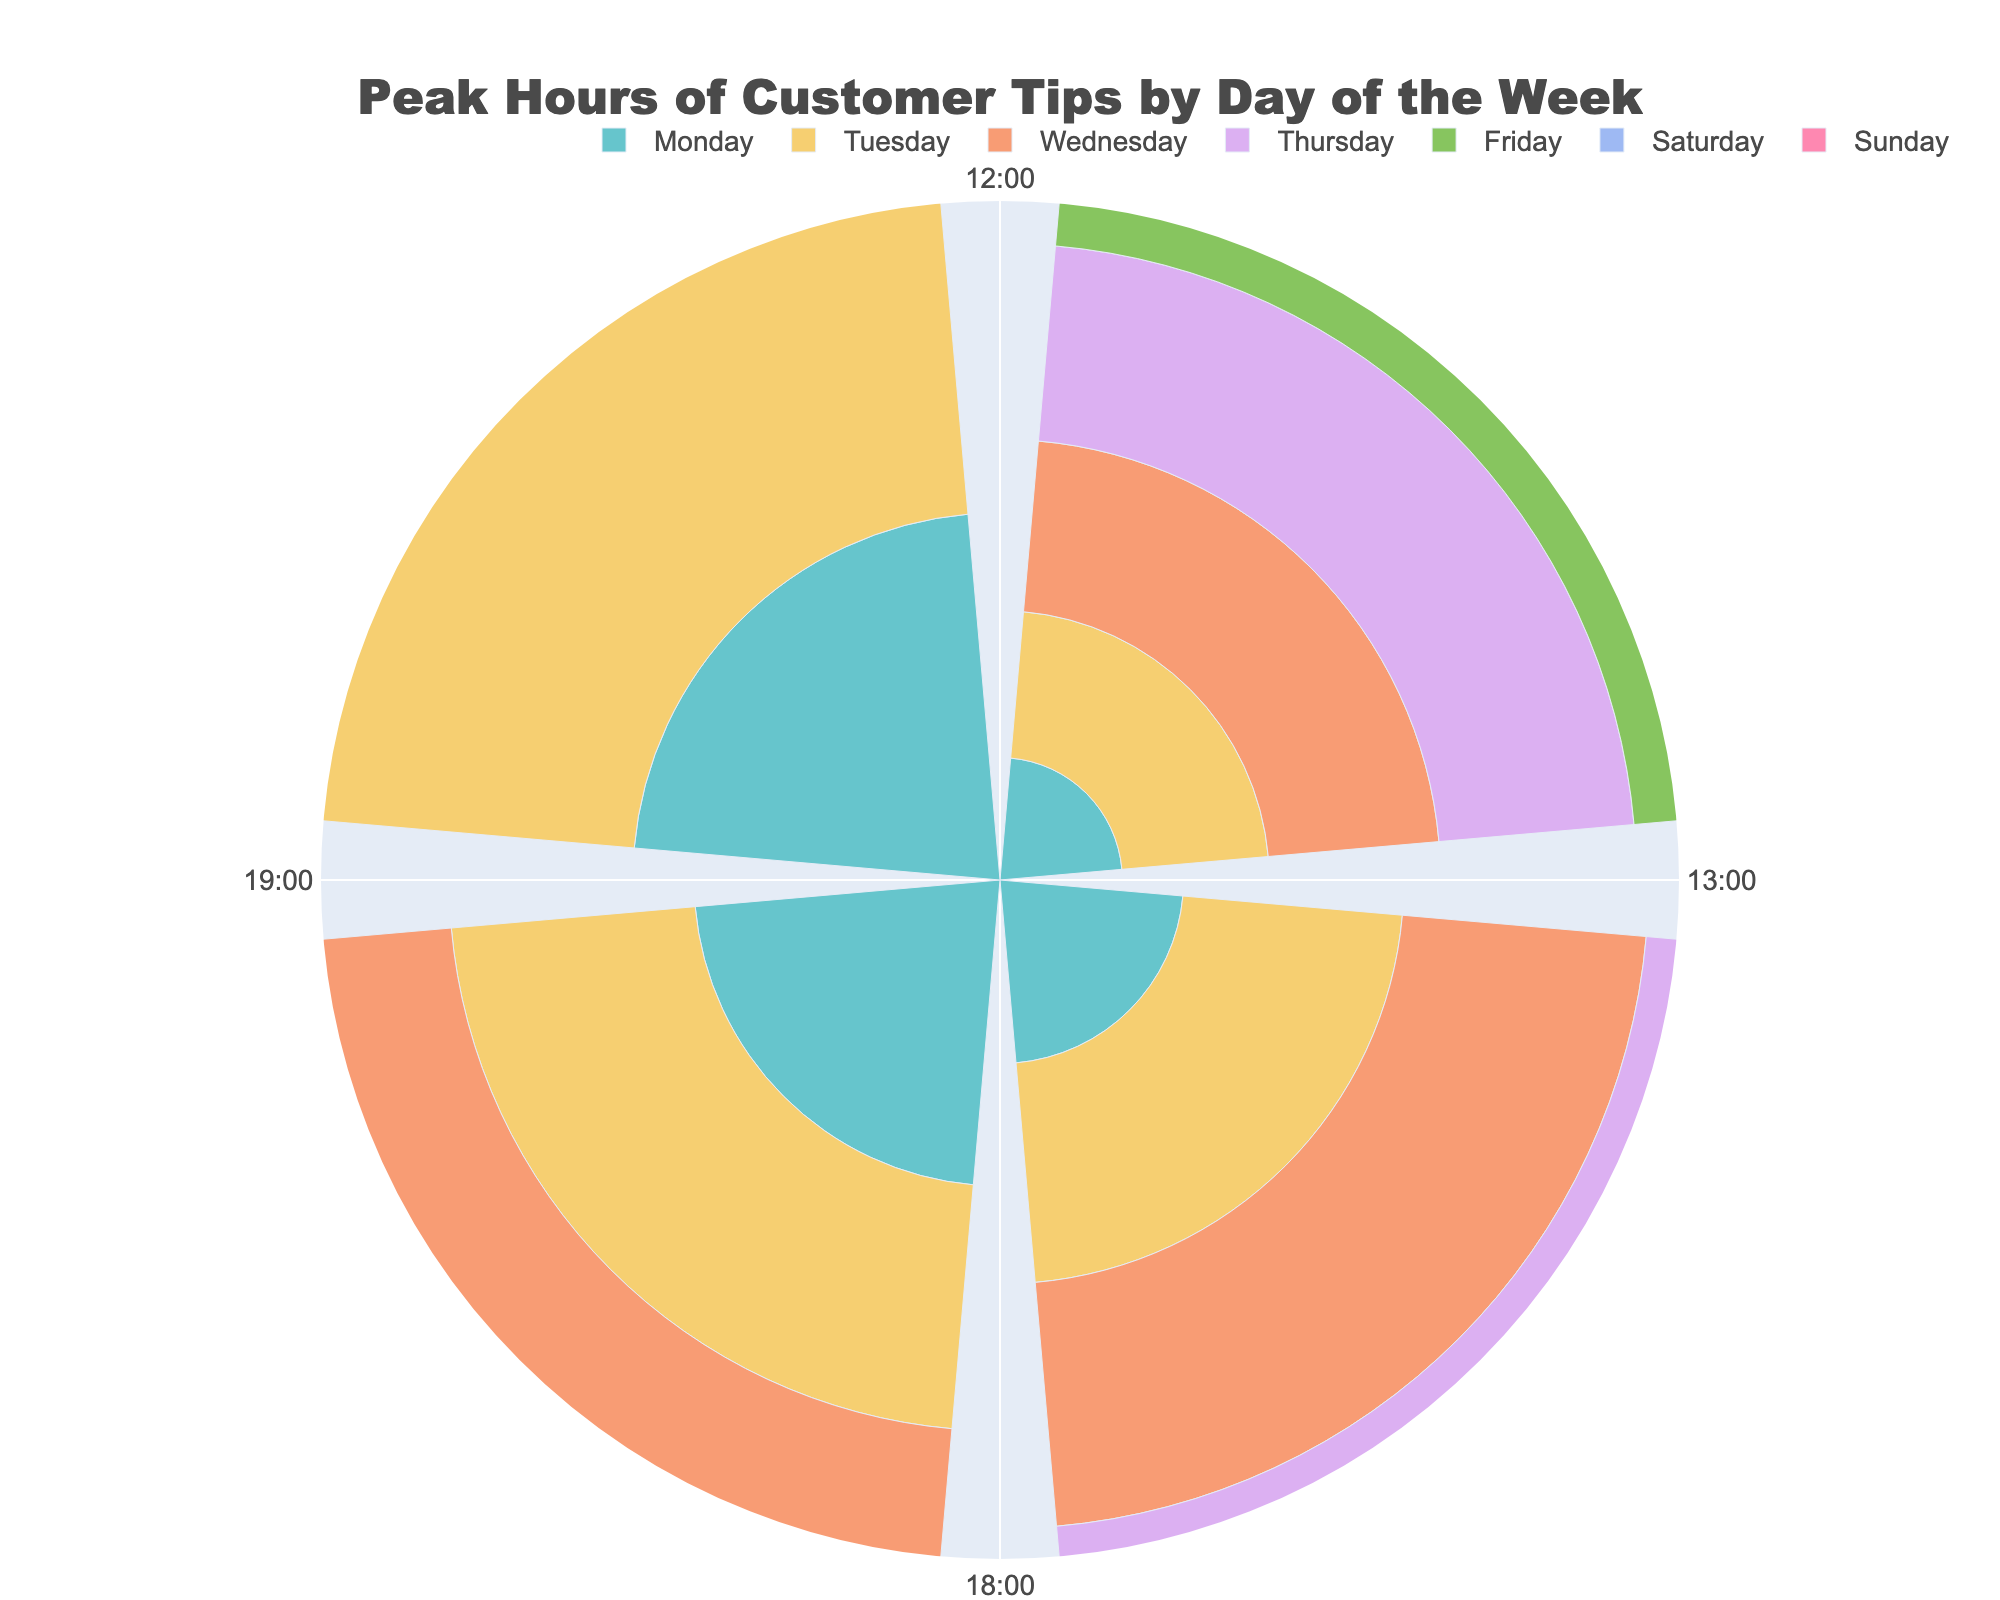What is the title of the rose chart? The title is usually placed prominently at the top of the figure. In this case, it reads "Peak Hours of Customer Tips by Day of the Week".
Answer: Peak Hours of Customer Tips by Day of the Week Which day has the highest average tips at 19:00? Look at the 19:00 data points for each day. The longest bar at 19:00 corresponds to Saturday with an average tip amount of 50.
Answer: Saturday What are the tick labels around the polar axis? The tick labels can be found around the angular axis of the polar chart. They are "12:00", "13:00", "18:00", and "19:00".
Answer: 12:00, 13:00, 18:00, 19:00 On which day do the average tips at 12:00 show the lowest value, and what is that value? Compare the lengths of the bars at 12:00 for each day. The shortest bar at 12:00 is on Monday with an average tip of 10.
Answer: Monday, 10 What is the color of the bars representing Friday? The colors for each day can be identified by looking at the legend. According to the color scheme, the bars for Friday are shown in a specific pastel color.
Answer: Pastel color for Friday (refer to the chart) Which day shows the greatest increase in average tips from 13:00 to 19:00? Compare the average tips at 13:00 and 19:00 for each day and find the day with the largest difference. Saturday has an increase from 28 at 13:00 to 50 at 19:00, a difference of 22.
Answer: Saturday What is the angular position for the 13:00 time slot in the polar chart? The angular positions for the time slots are designated by specific angles. The slot for 13:00 is positioned at 90 degrees.
Answer: 90 degrees During which hours does Wednesday have the highest average tips? Check the average tip values for Wednesday at each time slot. The highest value on Wednesday is at 19:00, with an average tip of 35.
Answer: 19:00 Identify the average tip amount at 18:00 for Thursday and compare it to Tuesday at the same time. Which day has higher tips? Look at the bars for 18:00 on both Thursday and Tuesday. Thursday has an average of 24, while Tuesday has 20. Therefore, Thursday has higher tips.
Answer: Thursday, 24 vs. 20 What can you infer about the general trend of average tips from 12:00 to 19:00 over the week? The general trend can be observed by looking at the lengths of the bars for each day from 12:00 to 19:00. Generally, the average tips increase as the hour progresses, particularly peaking at 19:00 across all days.
Answer: Increasing trend, peaking at 19:00 